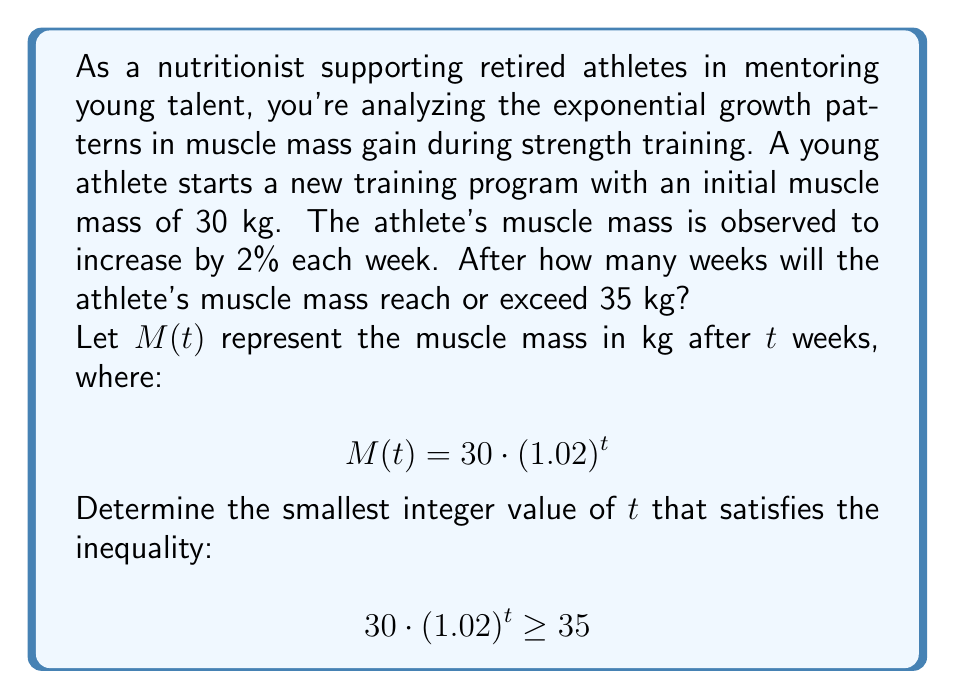Teach me how to tackle this problem. To solve this problem, we'll use the properties of exponential functions and logarithms:

1) First, we start with the inequality:
   $$30 \cdot (1.02)^t \geq 35$$

2) Divide both sides by 30:
   $$(1.02)^t \geq \frac{35}{30} = \frac{7}{6}$$

3) Take the natural logarithm of both sides:
   $$\ln((1.02)^t) \geq \ln(\frac{7}{6})$$

4) Use the logarithm property $\ln(a^b) = b\ln(a)$:
   $$t \cdot \ln(1.02) \geq \ln(\frac{7}{6})$$

5) Divide both sides by $\ln(1.02)$:
   $$t \geq \frac{\ln(\frac{7}{6})}{\ln(1.02)}$$

6) Calculate the right-hand side:
   $$t \geq \frac{\ln(1.1666...)}{0.0198...} \approx 8.0121...$$

7) Since we need the smallest integer value of $t$, we round up to the next whole number:
   $$t = 9$$

Therefore, it will take 9 weeks for the athlete's muscle mass to reach or exceed 35 kg.
Answer: 9 weeks 